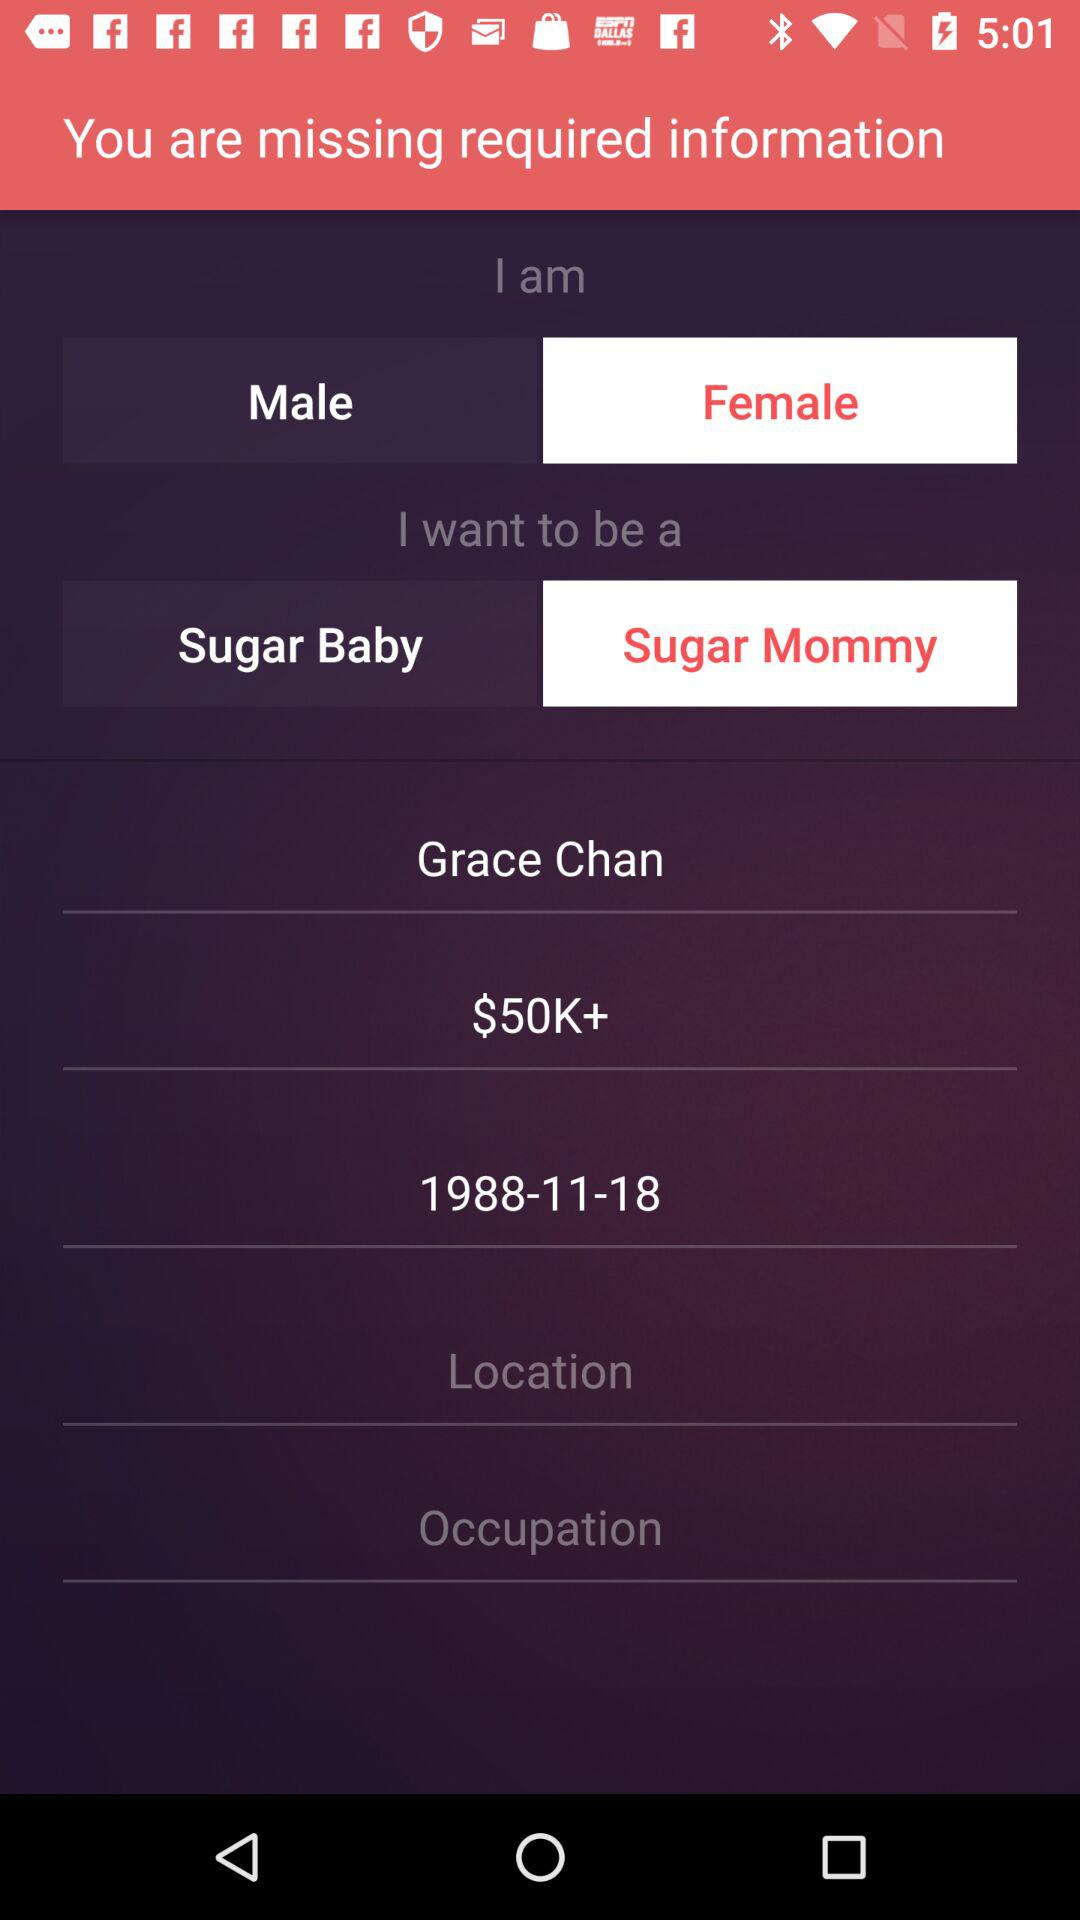How many text inputs are there for occupation?
Answer the question using a single word or phrase. 1 